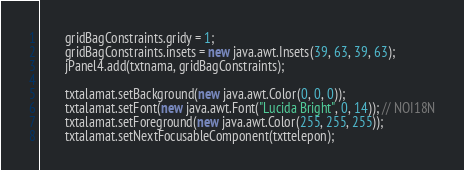Convert code to text. <code><loc_0><loc_0><loc_500><loc_500><_Java_>        gridBagConstraints.gridy = 1;
        gridBagConstraints.insets = new java.awt.Insets(39, 63, 39, 63);
        jPanel4.add(txtnama, gridBagConstraints);

        txtalamat.setBackground(new java.awt.Color(0, 0, 0));
        txtalamat.setFont(new java.awt.Font("Lucida Bright", 0, 14)); // NOI18N
        txtalamat.setForeground(new java.awt.Color(255, 255, 255));
        txtalamat.setNextFocusableComponent(txttelepon);</code> 